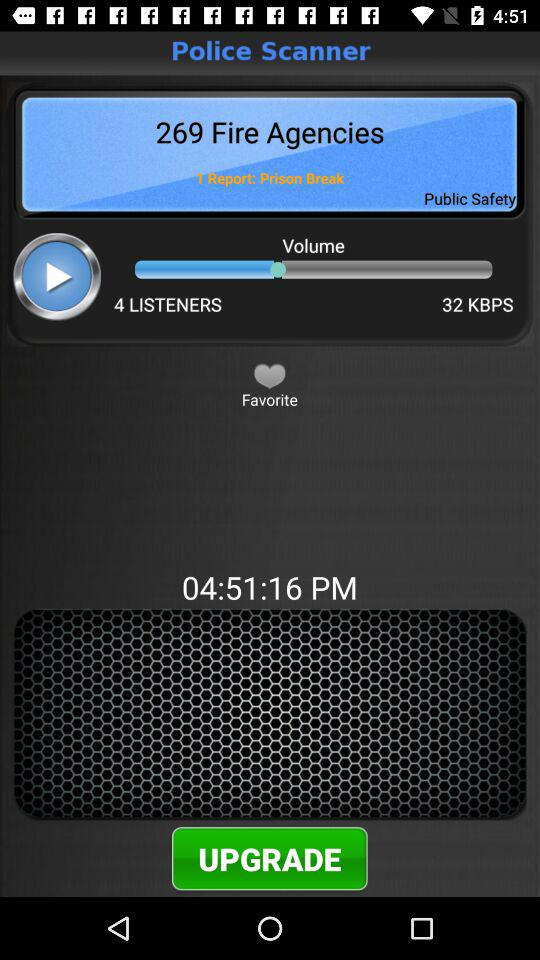How many listeners are there? There are 4 listeners. 